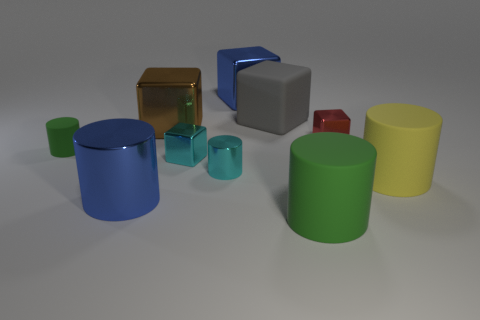Subtract all tiny shiny cylinders. How many cylinders are left? 4 Subtract all cyan blocks. How many blocks are left? 4 Subtract all yellow cylinders. How many cyan cubes are left? 1 Subtract all green cylinders. Subtract all cyan spheres. How many cylinders are left? 3 Subtract all small metal cylinders. Subtract all tiny cyan metal cubes. How many objects are left? 8 Add 5 small cyan metal cylinders. How many small cyan metal cylinders are left? 6 Add 4 big blue shiny blocks. How many big blue shiny blocks exist? 5 Subtract 0 brown spheres. How many objects are left? 10 Subtract 2 cubes. How many cubes are left? 3 